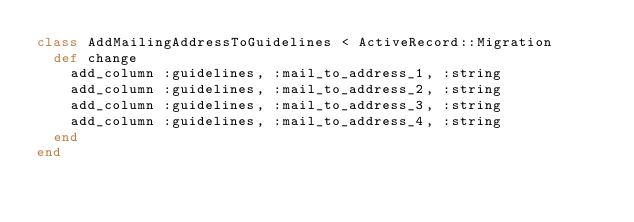<code> <loc_0><loc_0><loc_500><loc_500><_Ruby_>class AddMailingAddressToGuidelines < ActiveRecord::Migration
  def change
    add_column :guidelines, :mail_to_address_1, :string
    add_column :guidelines, :mail_to_address_2, :string
    add_column :guidelines, :mail_to_address_3, :string
    add_column :guidelines, :mail_to_address_4, :string
  end
end
</code> 